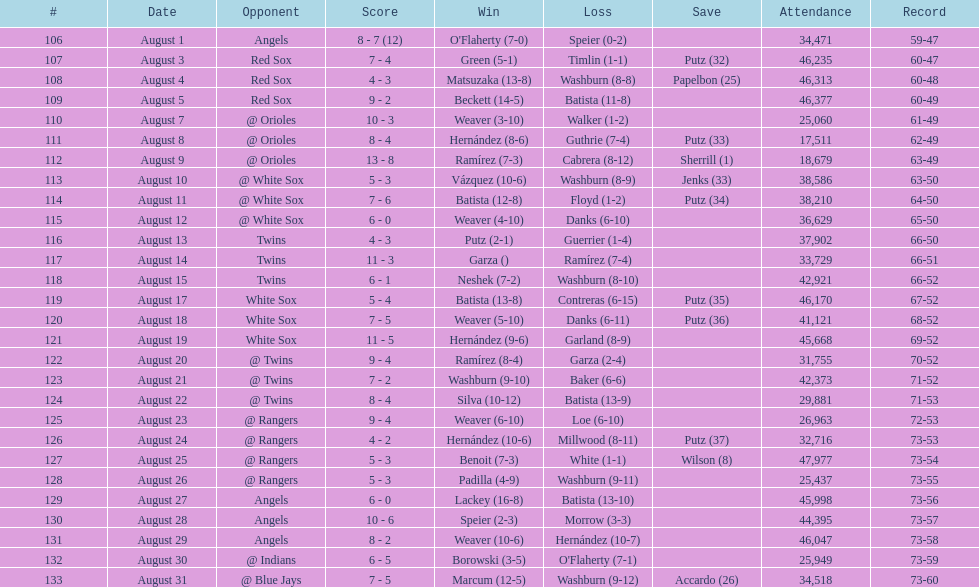Largest run differential 8. 